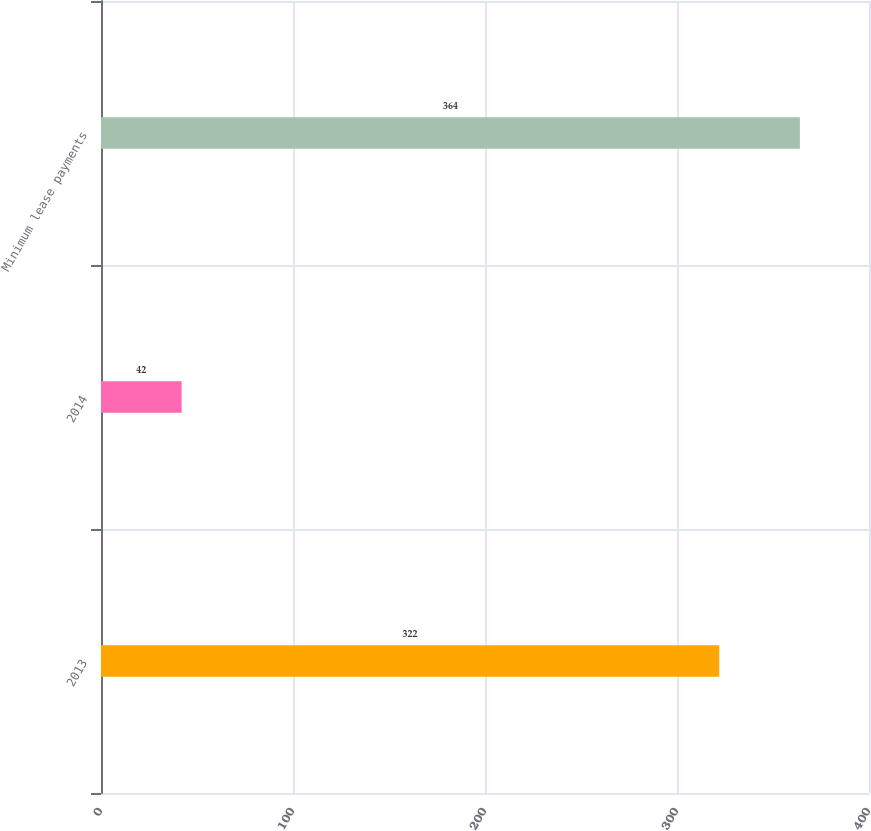Convert chart. <chart><loc_0><loc_0><loc_500><loc_500><bar_chart><fcel>2013<fcel>2014<fcel>Minimum lease payments<nl><fcel>322<fcel>42<fcel>364<nl></chart> 